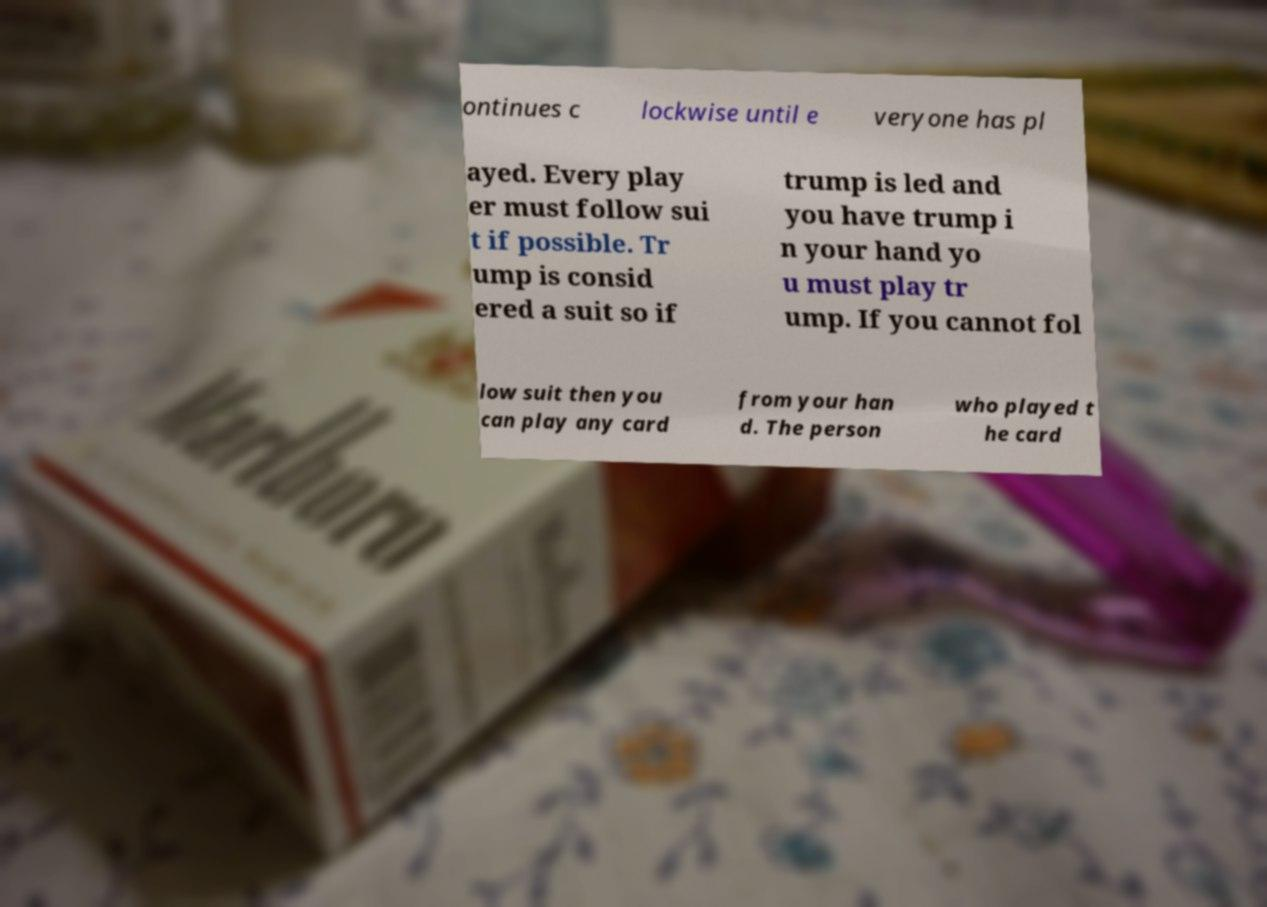Can you read and provide the text displayed in the image?This photo seems to have some interesting text. Can you extract and type it out for me? ontinues c lockwise until e veryone has pl ayed. Every play er must follow sui t if possible. Tr ump is consid ered a suit so if trump is led and you have trump i n your hand yo u must play tr ump. If you cannot fol low suit then you can play any card from your han d. The person who played t he card 